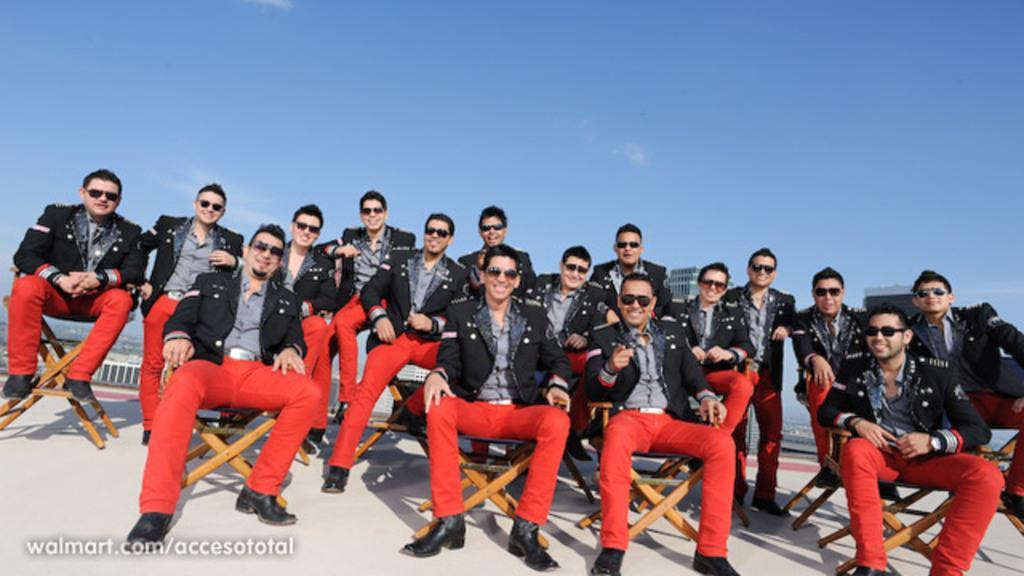Describe this image in one or two sentences. A group of men are sitting, they wore black color coats, spectacles, shoes and red color trousers. At the top it's a sky. 